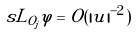Convert formula to latex. <formula><loc_0><loc_0><loc_500><loc_500>\ s L _ { O _ { j } } \varphi = { O } ( | u | ^ { - 2 } )</formula> 